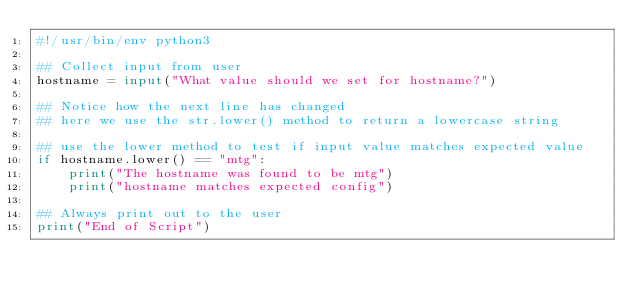Convert code to text. <code><loc_0><loc_0><loc_500><loc_500><_Python_>#!/usr/bin/env python3

## Collect input from user
hostname = input("What value should we set for hostname?")

## Notice how the next line has changed
## here we use the str.lower() method to return a lowercase string

## use the lower method to test if input value matches expected value
if hostname.lower() == "mtg":
    print("The hostname was found to be mtg")
    print("hostname matches expected config")

## Always print out to the user
print("End of Script")
</code> 